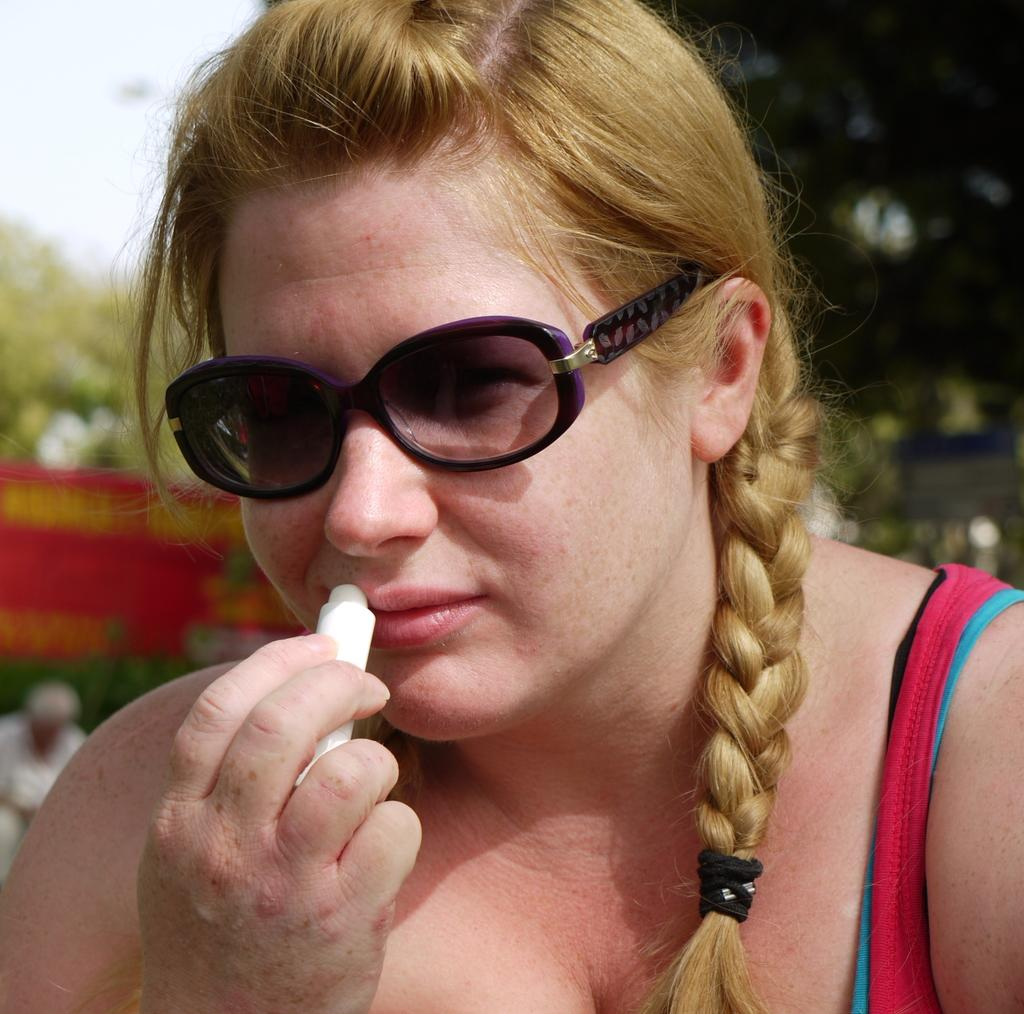Who is the main subject in the image? There is a lady in the image. What is the lady wearing on her face? The lady is wearing goggles. What object is the lady holding in her hand? The lady is holding a lip balm. Can you describe the background of the image? The background of the image is blurred. What type of birds can be seen flying in the background of the image? There are no birds visible in the image; the background is blurred. 